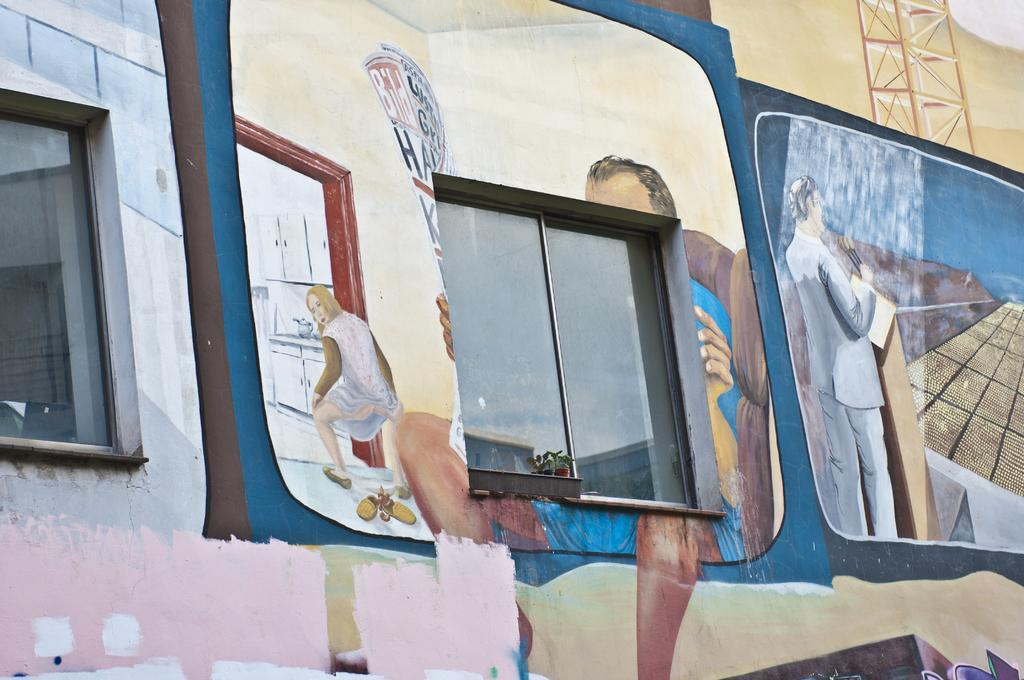What is the main subject of the image? There is a painting in the image. Where is the painting located? The painting is on a wall. What else can be seen in the image besides the painting? There are windows in the image. What is depicted in the painting? The painting depicts people with different color dresses. How many folds can be seen in the dresses of the people in the painting? The provided facts do not mention any folds in the dresses of the people depicted in the painting. 